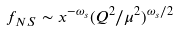Convert formula to latex. <formula><loc_0><loc_0><loc_500><loc_500>f _ { N S } \sim x ^ { - \omega _ { s } } ( Q ^ { 2 } / \mu ^ { 2 } ) ^ { \omega _ { s } / 2 }</formula> 